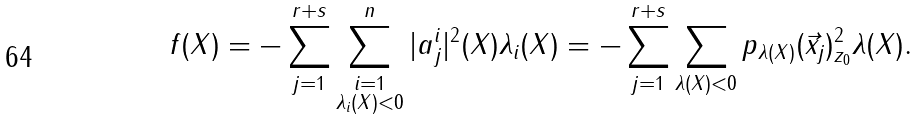Convert formula to latex. <formula><loc_0><loc_0><loc_500><loc_500>f ( X ) = - \sum _ { j = 1 } ^ { r + s } \sum _ { \substack { i = 1 \\ \lambda _ { i } ( X ) < 0 } } ^ { n } | a _ { j } ^ { i } | ^ { 2 } ( X ) \lambda _ { i } ( X ) = - \sum _ { j = 1 } ^ { r + s } \sum _ { \lambda ( X ) < 0 } \| p _ { \lambda ( X ) } ( \vec { x } _ { j } ) \| ^ { 2 } _ { z _ { 0 } } \lambda ( X ) .</formula> 